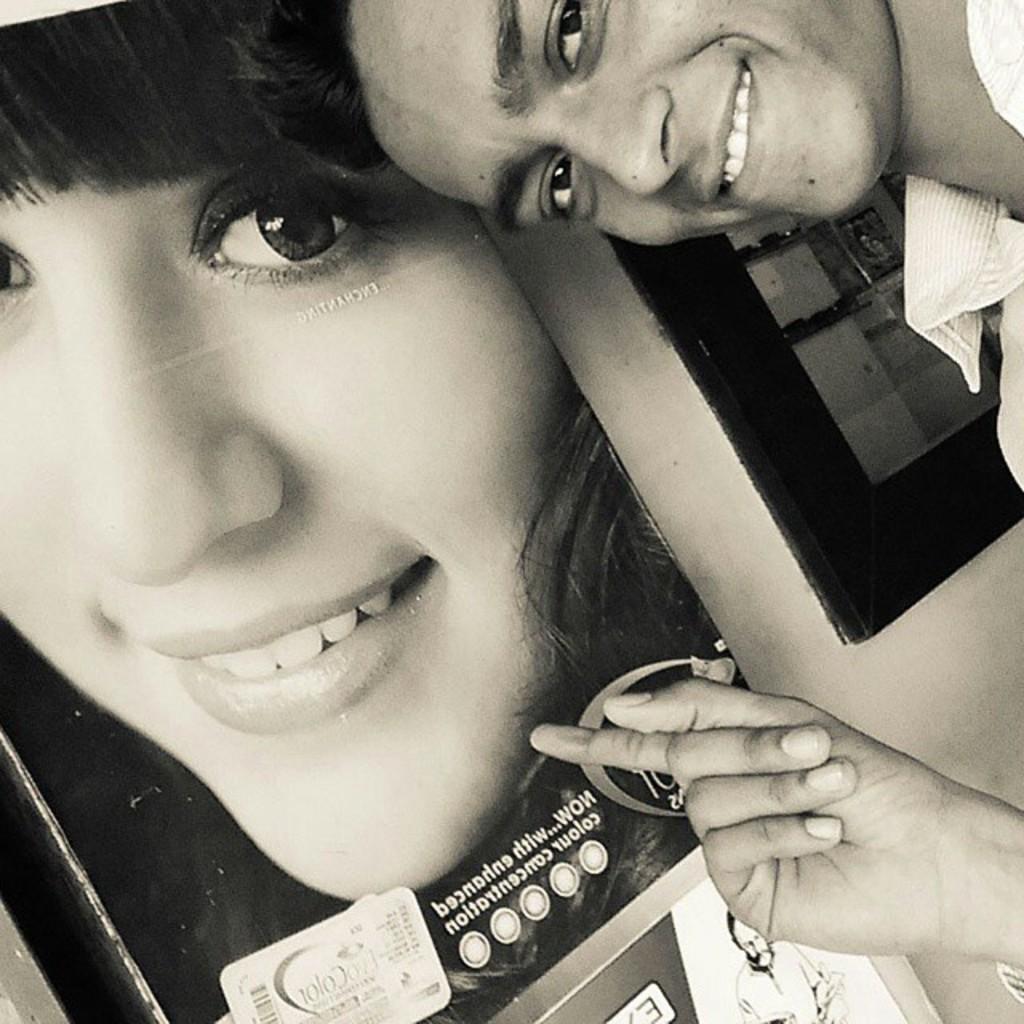Describe this image in one or two sentences. In this picture I see a man on the right side of this picture and I see that he is smiling. In the background I can see a poster on which there is a photo of a woman, who is smiling and I see something is written on the poster and I see the wall. 